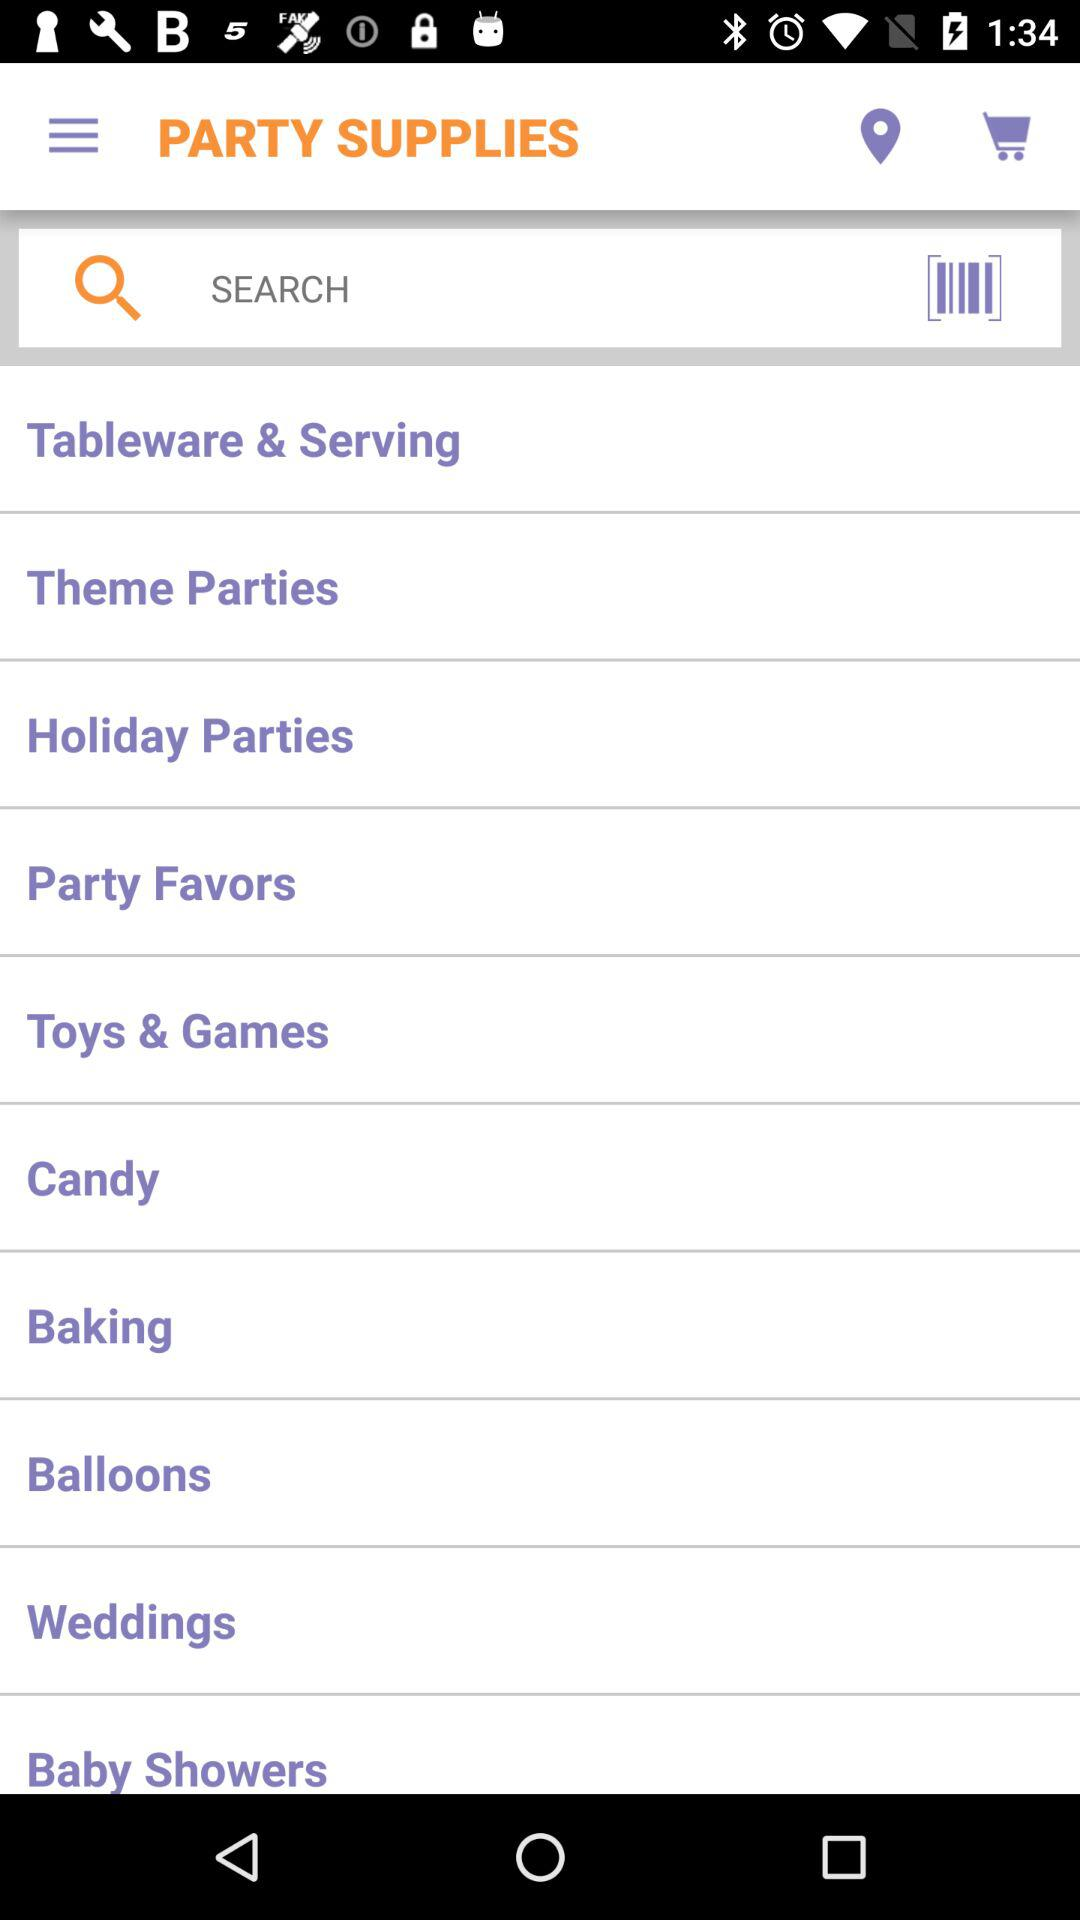What is entered into the search bar?
When the provided information is insufficient, respond with <no answer>. <no answer> 